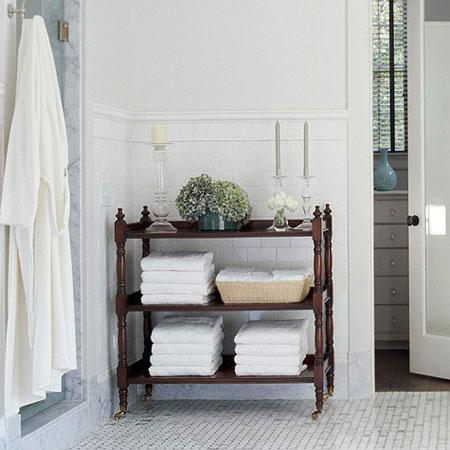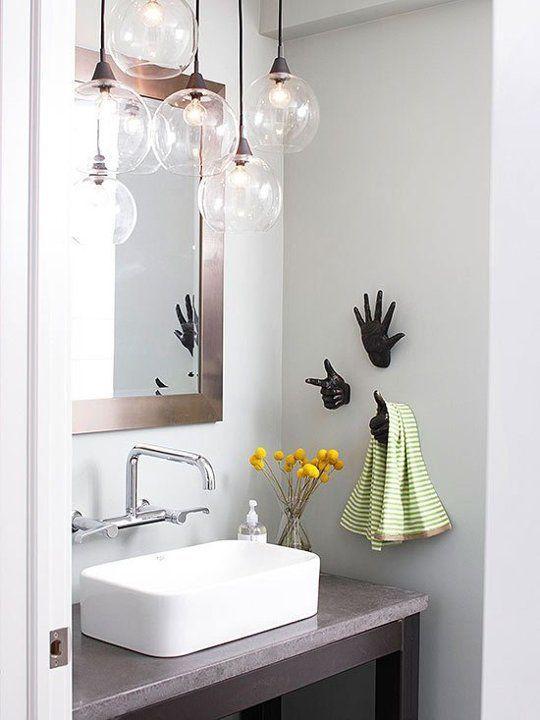The first image is the image on the left, the second image is the image on the right. Given the left and right images, does the statement "There are at least two mirrors visible hanging on the walls." hold true? Answer yes or no. No. The first image is the image on the left, the second image is the image on the right. Considering the images on both sides, is "In one image, a white pedestal sink stands against a wall." valid? Answer yes or no. No. 